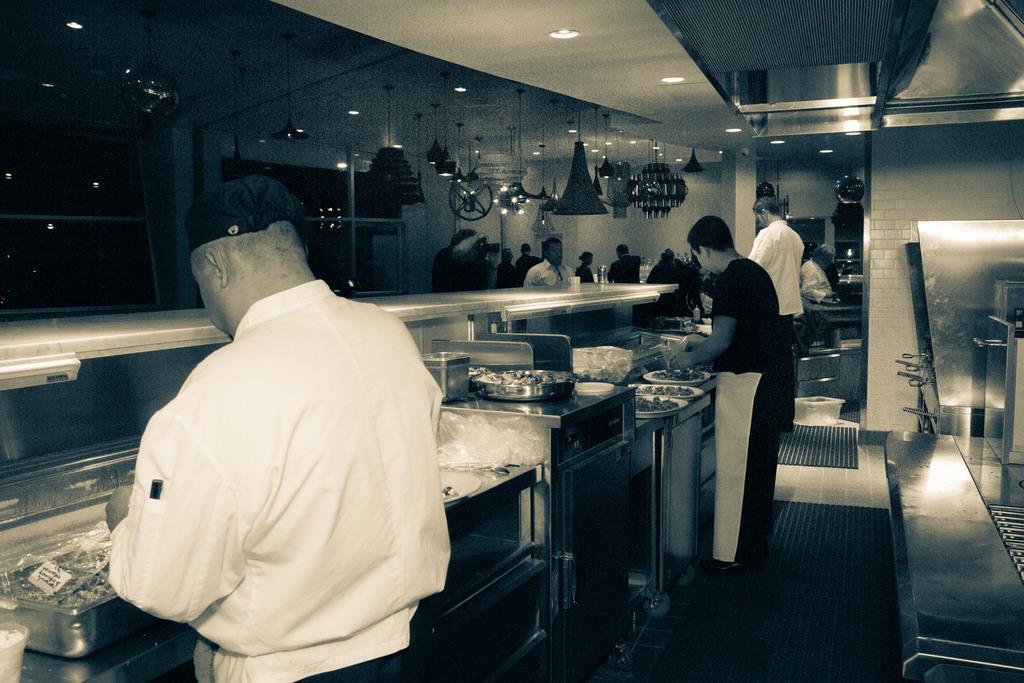Please provide a concise description of this image. In this image I can see on the left side there is a man, he is wearing the white color shirt and a black color cap. It looks like a kitchen room, in the middle two persons are standing near the plates. In the background a group of people are there, at the top there are ceiling lights. 